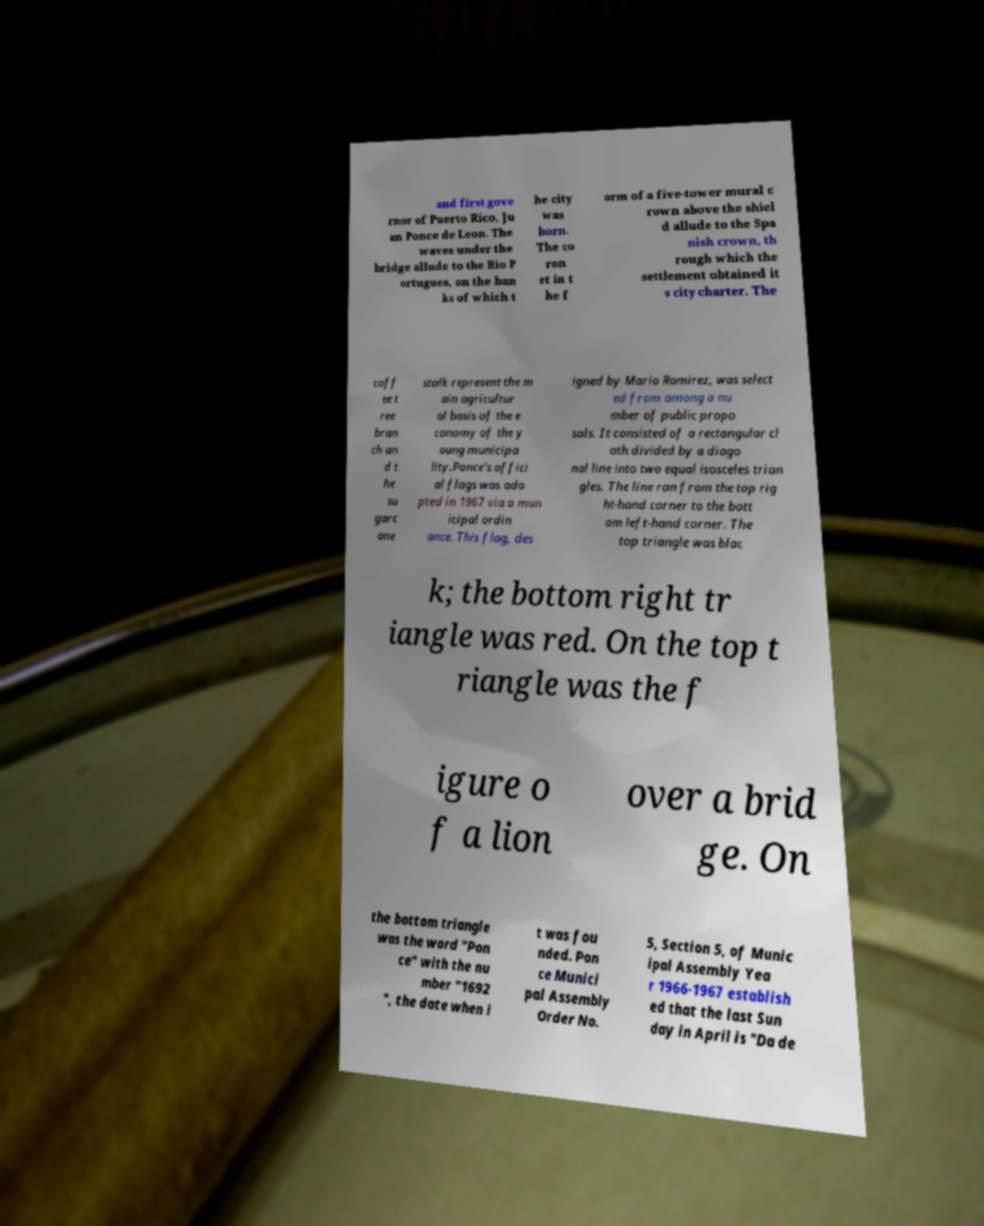Please identify and transcribe the text found in this image. and first gove rnor of Puerto Rico, Ju an Ponce de Leon. The waves under the bridge allude to the Rio P ortugues, on the ban ks of which t he city was born. The co ron et in t he f orm of a five-tower mural c rown above the shiel d allude to the Spa nish crown, th rough which the settlement obtained it s city charter. The coff ee t ree bran ch an d t he su garc ane stalk represent the m ain agricultur al basis of the e conomy of the y oung municipa lity.Ponce's offici al flags was ado pted in 1967 via a mun icipal ordin ance. This flag, des igned by Mario Ramirez, was select ed from among a nu mber of public propo sals. It consisted of a rectangular cl oth divided by a diago nal line into two equal isosceles trian gles. The line ran from the top rig ht-hand corner to the bott om left-hand corner. The top triangle was blac k; the bottom right tr iangle was red. On the top t riangle was the f igure o f a lion over a brid ge. On the bottom triangle was the word "Pon ce" with the nu mber "1692 ", the date when i t was fou nded. Pon ce Munici pal Assembly Order No. 5, Section 5, of Munic ipal Assembly Yea r 1966-1967 establish ed that the last Sun day in April is "Da de 